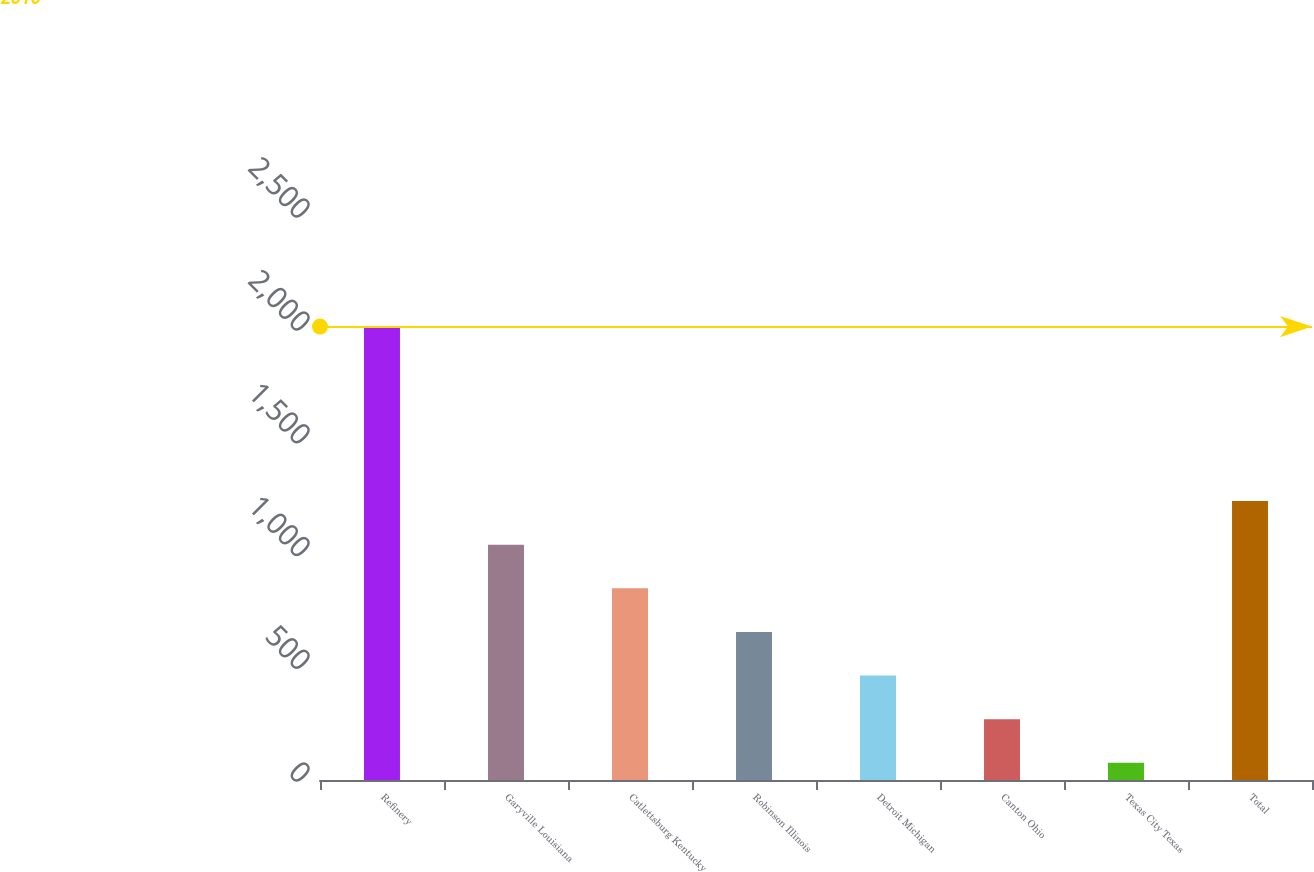Convert chart to OTSL. <chart><loc_0><loc_0><loc_500><loc_500><bar_chart><fcel>Refinery<fcel>Garyville Louisiana<fcel>Catlettsburg Kentucky<fcel>Robinson Illinois<fcel>Detroit Michigan<fcel>Canton Ohio<fcel>Texas City Texas<fcel>Total<nl><fcel>2010<fcel>1043<fcel>849.6<fcel>656.2<fcel>462.8<fcel>269.4<fcel>76<fcel>1236.4<nl></chart> 